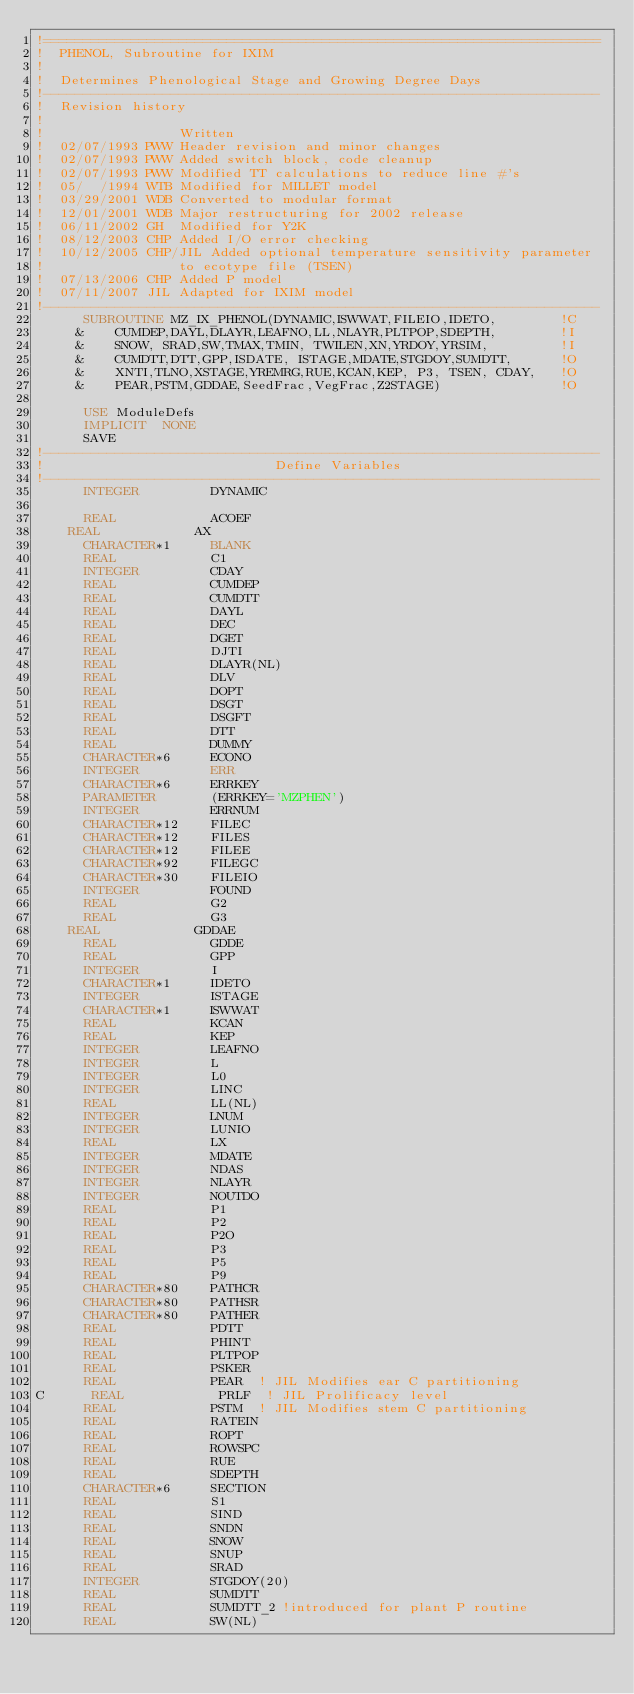Convert code to text. <code><loc_0><loc_0><loc_500><loc_500><_FORTRAN_>!======================================================================
!  PHENOL, Subroutine for IXIM
!
!  Determines Phenological Stage and Growing Degree Days
!----------------------------------------------------------------------
!  Revision history
!
!                 Written
!  02/07/1993 PWW Header revision and minor changes                 
!  02/07/1993 PWW Added switch block, code cleanup                  
!  02/07/1993 PWW Modified TT calculations to reduce line #'s       
!  05/  /1994 WTB Modified for MILLET model                        
!  03/29/2001 WDB Converted to modular format                      
!  12/01/2001 WDB Major restructuring for 2002 release                    
!  06/11/2002 GH  Modified for Y2K
!  08/12/2003 CHP Added I/O error checking
!  10/12/2005 CHP/JIL Added optional temperature sensitivity parameter
!                 to ecotype file (TSEN)
!  07/13/2006 CHP Added P model
!  07/11/2007 JIL Adapted for IXIM model
!----------------------------------------------------------------------
      SUBROUTINE MZ_IX_PHENOL(DYNAMIC,ISWWAT,FILEIO,IDETO,        !C
     &    CUMDEP,DAYL,DLAYR,LEAFNO,LL,NLAYR,PLTPOP,SDEPTH,        !I
     &    SNOW, SRAD,SW,TMAX,TMIN, TWILEN,XN,YRDOY,YRSIM,         !I
     &    CUMDTT,DTT,GPP,ISDATE, ISTAGE,MDATE,STGDOY,SUMDTT,      !O
     &    XNTI,TLNO,XSTAGE,YREMRG,RUE,KCAN,KEP, P3, TSEN, CDAY,   !O
     &    PEAR,PSTM,GDDAE,SeedFrac,VegFrac,Z2STAGE)               !O

      USE ModuleDefs
      IMPLICIT  NONE
      SAVE
!----------------------------------------------------------------------
!                             Define Variables
!----------------------------------------------------------------------
      INTEGER         DYNAMIC         

      REAL            ACOEF           
	REAL            AX
      CHARACTER*1     BLANK         
      REAL            C1   
      INTEGER         CDAY 
      REAL            CUMDEP          
      REAL            CUMDTT          
      REAL            DAYL            
      REAL            DEC             
      REAL            DGET
      REAL            DJTI
      REAL            DLAYR(NL)       
      REAL            DLV             
      REAL            DOPT                      
      REAL            DSGT
      REAL            DSGFT
      REAL            DTT             
      REAL            DUMMY           
      CHARACTER*6     ECONO           
      INTEGER         ERR             
      CHARACTER*6     ERRKEY          
      PARAMETER       (ERRKEY='MZPHEN')
      INTEGER         ERRNUM
      CHARACTER*12    FILEC     
      CHARACTER*12    FILES
      CHARACTER*12    FILEE     
      CHARACTER*92    FILEGC
      CHARACTER*30    FILEIO         
      INTEGER         FOUND          
      REAL            G2             
      REAL            G3             
	REAL            GDDAE
      REAL            GDDE
      REAL            GPP            
      INTEGER         I              
      CHARACTER*1     IDETO          
      INTEGER         ISTAGE         
      CHARACTER*1     ISWWAT         
      REAL            KCAN
      REAL            KEP
      INTEGER         LEAFNO         
      INTEGER         L              
      INTEGER         L0             
      INTEGER         LINC           
      REAL            LL(NL)         
      INTEGER         LNUM           
      INTEGER         LUNIO          
      REAL            LX
      INTEGER         MDATE          
      INTEGER         NDAS           
      INTEGER         NLAYR          
      INTEGER         NOUTDO         
      REAL            P1             
      REAL            P2             
      REAL            P2O            
      REAL            P3             
      REAL            P5             
      REAL            P9             
      CHARACTER*80    PATHCR 
      CHARACTER*80    PATHSR
      CHARACTER*80    PATHER        
      REAL            PDTT
      REAL            PHINT          
      REAL            PLTPOP         
      REAL            PSKER          
      REAL            PEAR  ! JIL Modifies ear C partitioning
C      REAL            PRLF  ! JIL Prolificacy level
      REAL            PSTM  ! JIL Modifies stem C partitioning
      REAL            RATEIN         
      REAL            ROPT           
      REAL            ROWSPC         
      REAL            RUE
      REAL            SDEPTH         
      CHARACTER*6     SECTION        
      REAL            S1    
      REAL            SIND           
      REAL            SNDN           
      REAL            SNOW           
      REAL            SNUP           
      REAL            SRAD           
      INTEGER         STGDOY(20)     
      REAL            SUMDTT
      REAL            SUMDTT_2 !introduced for plant P routine         
      REAL            SW(NL)         </code> 